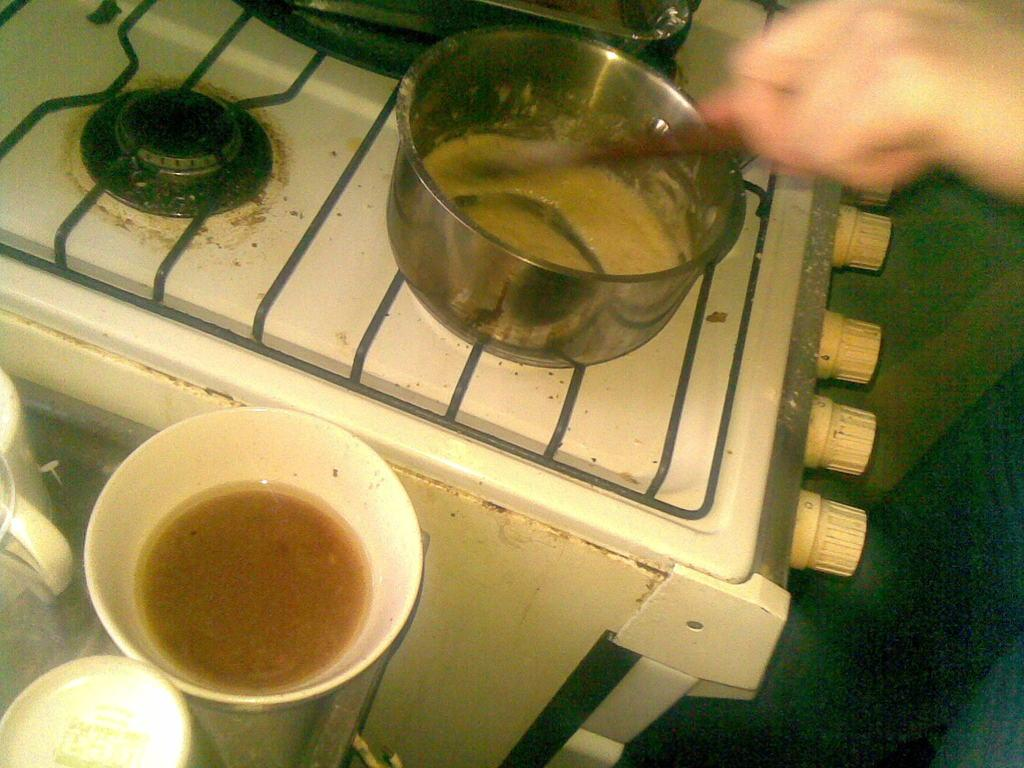What is being held by the human hand in the image? There is a human hand holding a spoon in the image. What can be seen in the background of the image? There is a stove in the image. What is on top of the stove? There is a metal container on the stove. What color are some of the objects in the image? There are other objects in the image that are white in color. What type of doctor is present in the image? There is no doctor present in the image. The image features a human hand holding a spoon, a stove, and a metal container on the stove. The image does not depict any medical professionals or any related context. 